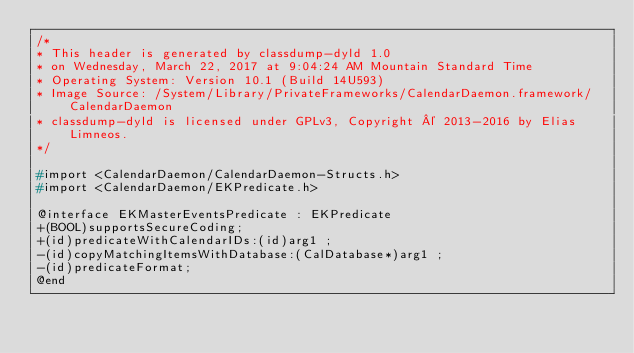Convert code to text. <code><loc_0><loc_0><loc_500><loc_500><_C_>/*
* This header is generated by classdump-dyld 1.0
* on Wednesday, March 22, 2017 at 9:04:24 AM Mountain Standard Time
* Operating System: Version 10.1 (Build 14U593)
* Image Source: /System/Library/PrivateFrameworks/CalendarDaemon.framework/CalendarDaemon
* classdump-dyld is licensed under GPLv3, Copyright © 2013-2016 by Elias Limneos.
*/

#import <CalendarDaemon/CalendarDaemon-Structs.h>
#import <CalendarDaemon/EKPredicate.h>

@interface EKMasterEventsPredicate : EKPredicate
+(BOOL)supportsSecureCoding;
+(id)predicateWithCalendarIDs:(id)arg1 ;
-(id)copyMatchingItemsWithDatabase:(CalDatabase*)arg1 ;
-(id)predicateFormat;
@end

</code> 